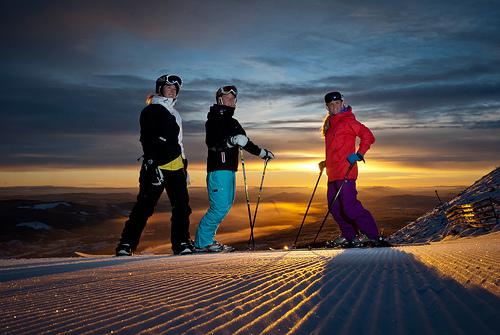Question: where are they standing?
Choices:
A. On a hill.
B. On a ramp.
C. On a mountain.
D. On a slope.
Answer with the letter. Answer: D Question: why are they wearing goggles?
Choices:
A. To protect eyes.
B. They are steampunk.
C. They are welding.
D. They are swimming.
Answer with the letter. Answer: A Question: what are they doing?
Choices:
A. Snowboarding.
B. Snowball fighting.
C. Skiing.
D. Vacationing.
Answer with the letter. Answer: C Question: what person has an orange parka?
Choices:
A. The one in the middle.
B. The one on the left.
C. The one on the ground.
D. The one on the right.
Answer with the letter. Answer: D 